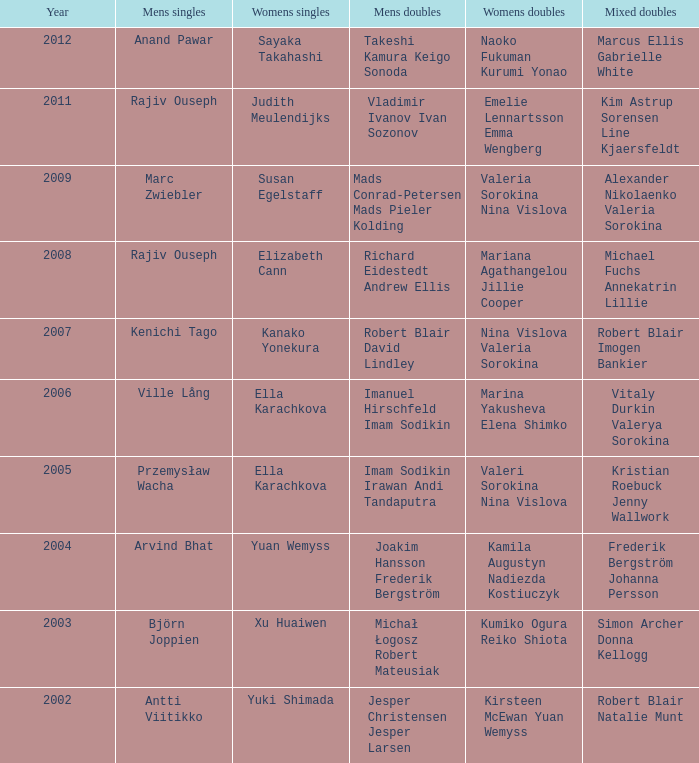What are the women's singles achievements of naoko fukuman and kurumi yonao? Sayaka Takahashi. 